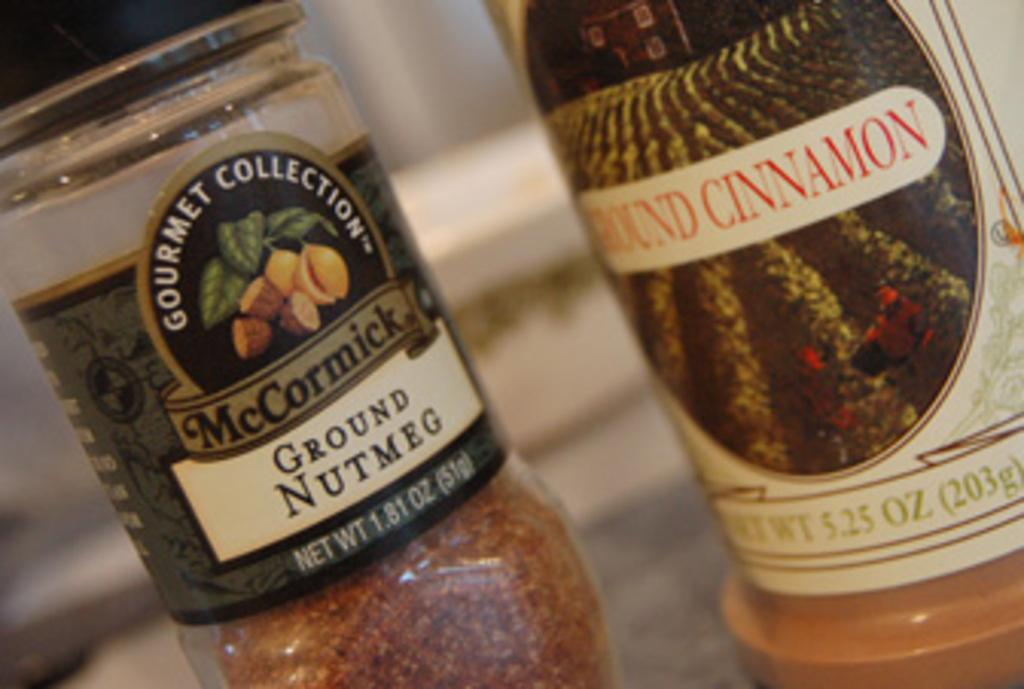How many bottles are visible in the image? There are two bottles in the image. What can be observed about the labels on the bottles? The labels on the bottles have white, red, black, and golden colors. How many dogs are wearing coats in the image? There are no dogs or coats present in the image; it only features two bottles with colored labels. 